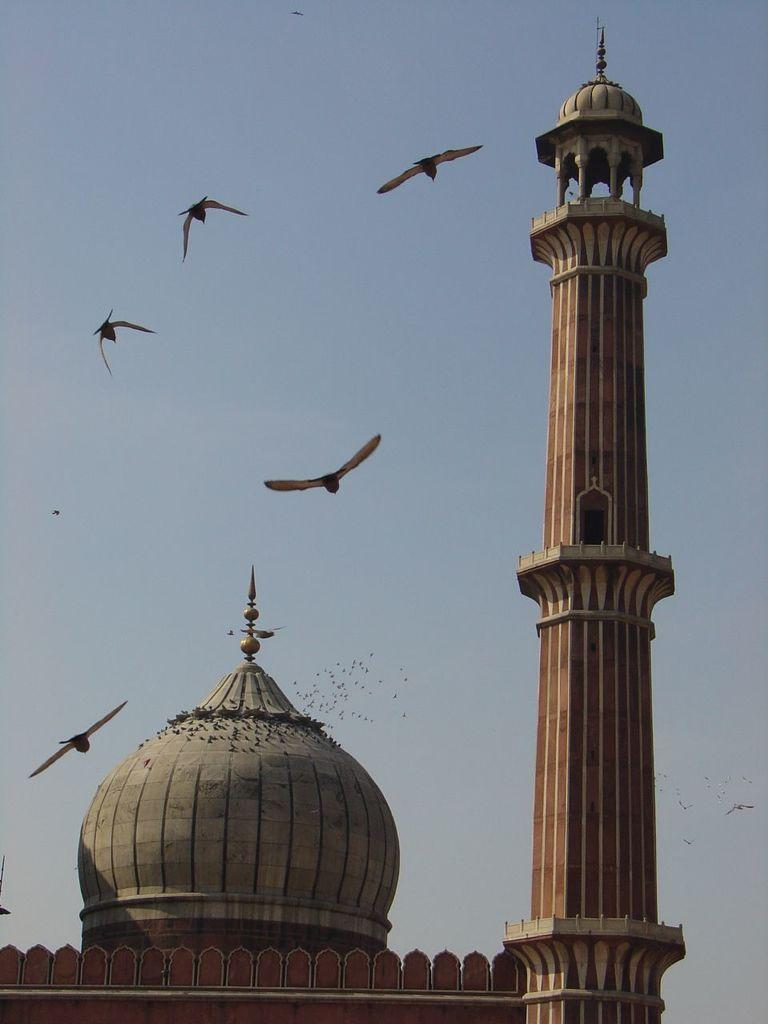What type of structure is depicted in the image? There is a monument in the image. What features can be seen on the monument? The monument has a tomb and a tower. What else is visible in the image besides the monument? There are birds flying in the air in the image. What is visible at the top of the image? The sky is visible at the top of the image. How does the truck compare to the monument in the image? There is no truck present in the image, so it cannot be compared to the monument. What type of wing is visible on the monument in the image? The monument in the image has a tower, but it does not have any wings. 